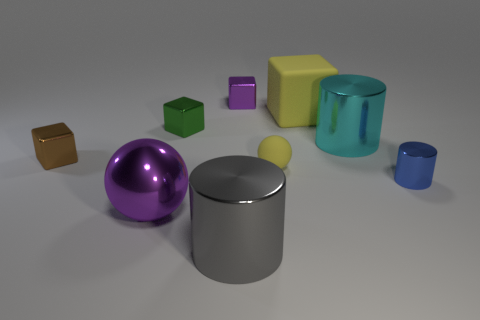How many blue objects are either small metallic cylinders or matte blocks? Upon inspection of the image, there appears to be only one blue object that fits the criteria of being a small metallic cylinder or matte block. It is a small blue metallic cylinder situated on the right side of the assembly of objects. 